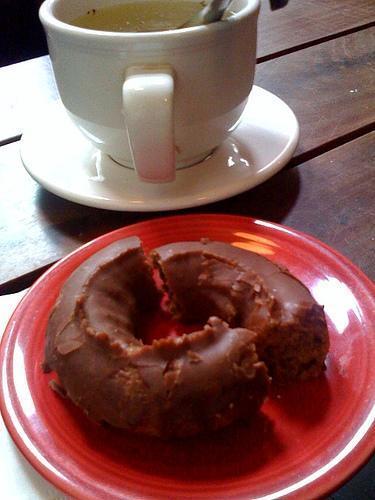How many donut halves are there?
Give a very brief answer. 2. How many donuts are on the plate?
Give a very brief answer. 1. 